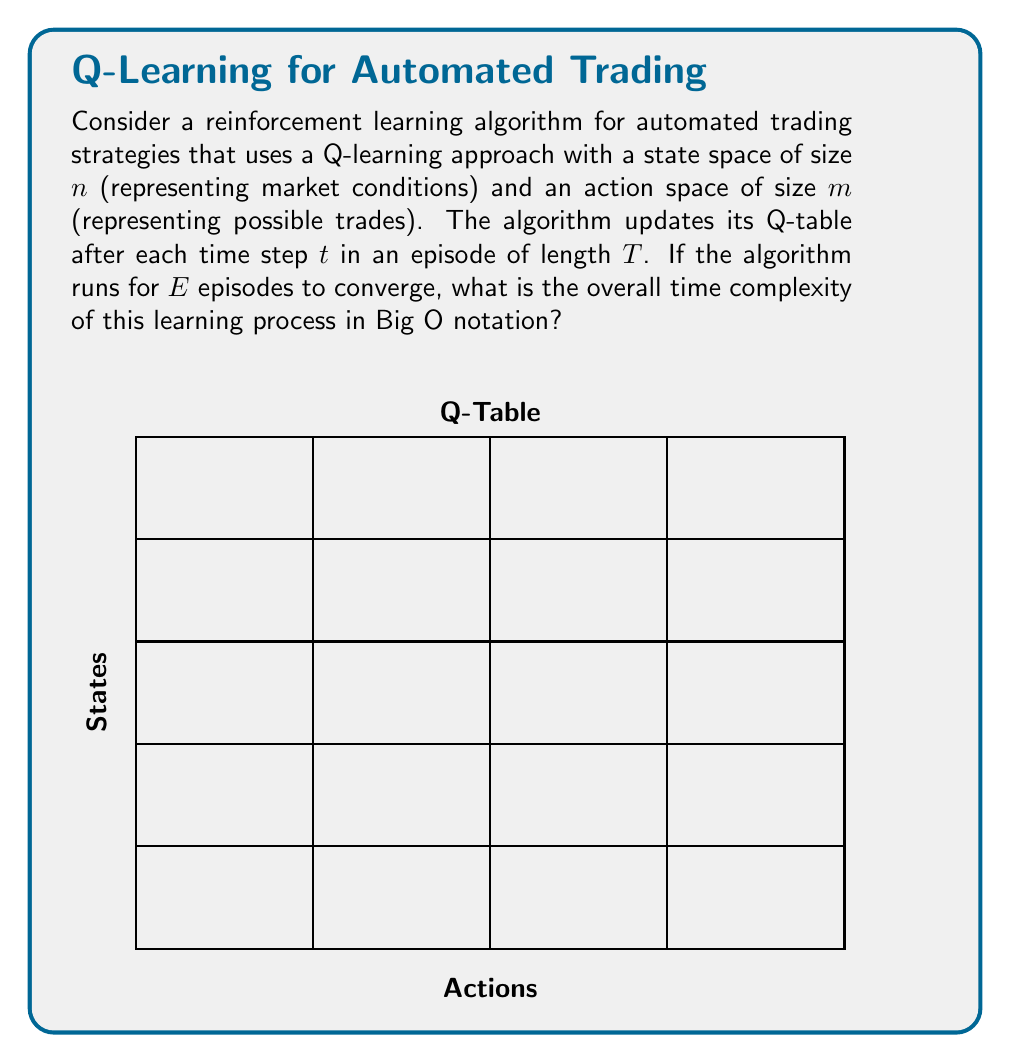Show me your answer to this math problem. Let's break down the problem and analyze the complexity step by step:

1) For each time step, the algorithm needs to:
   a) Choose an action: $O(m)$
   b) Observe the next state and reward: $O(1)$
   c) Update the Q-value for the current state-action pair: $O(1)$

2) The total operations per time step is thus $O(m)$.

3) Each episode consists of $T$ time steps, so the complexity per episode is:
   $O(T \cdot m)$

4) The algorithm runs for $E$ episodes, so the total complexity is:
   $O(E \cdot T \cdot m)$

5) However, we need to consider the state space size $n$ as well. In the worst case, each state-action pair in the Q-table might be updated, leading to a complexity of:
   $O(n \cdot m)$ for a complete update of the Q-table.

6) Combining this with the number of episodes, we get:
   $O(\max(E \cdot T \cdot m, n \cdot m))$

7) Since $n$, $m$, $E$, and $T$ are independent variables, we can't simplify this further without additional information about their relative sizes.

Therefore, the overall time complexity of the learning process is $O(\max(E \cdot T \cdot m, n \cdot m))$.
Answer: $O(\max(E \cdot T \cdot m, n \cdot m))$ 